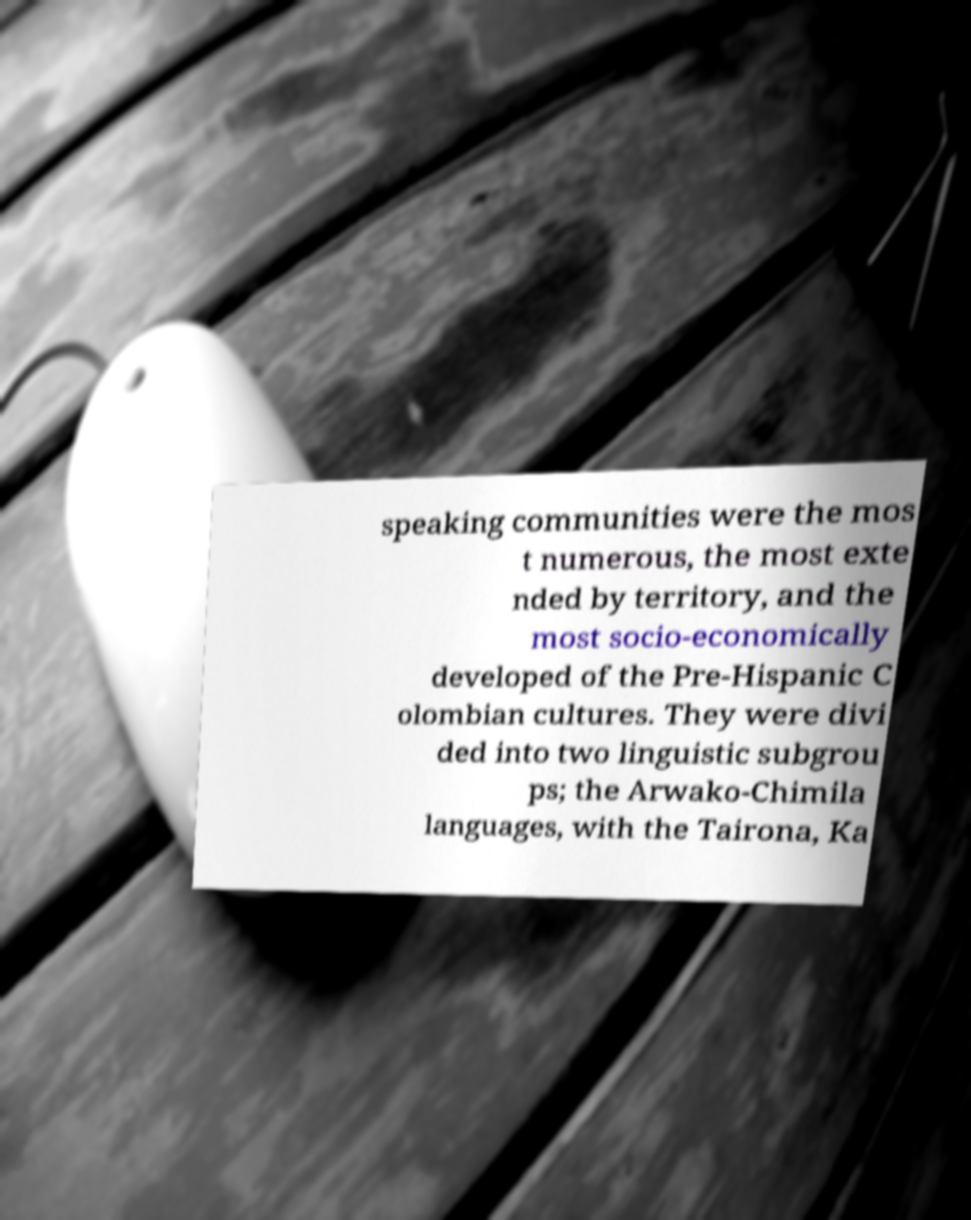Can you accurately transcribe the text from the provided image for me? speaking communities were the mos t numerous, the most exte nded by territory, and the most socio-economically developed of the Pre-Hispanic C olombian cultures. They were divi ded into two linguistic subgrou ps; the Arwako-Chimila languages, with the Tairona, Ka 